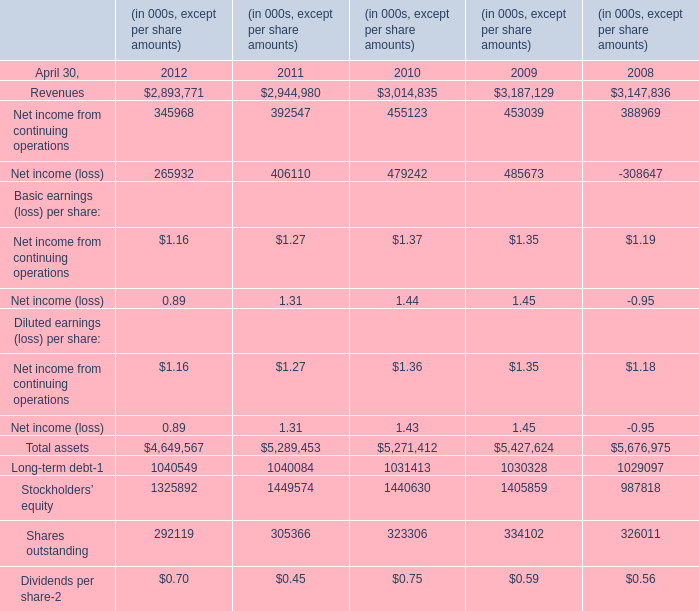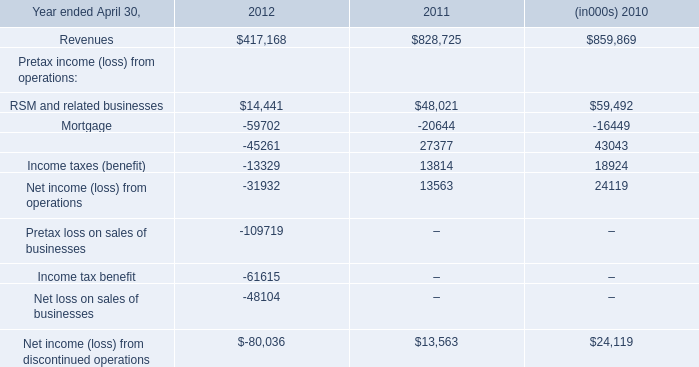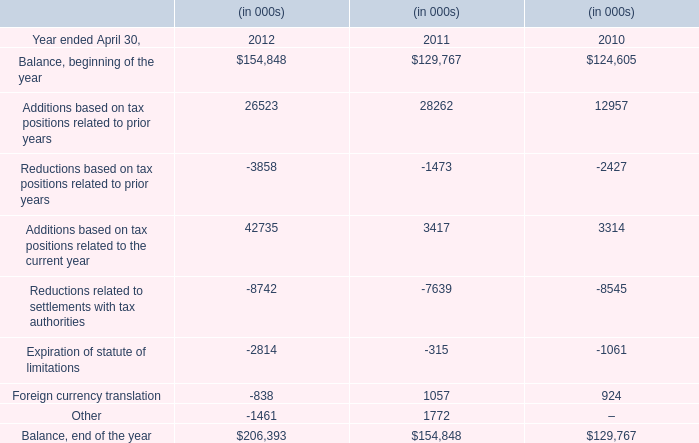The Net income from continuing operations of April 30,which year ranks first? 
Answer: 2010. 